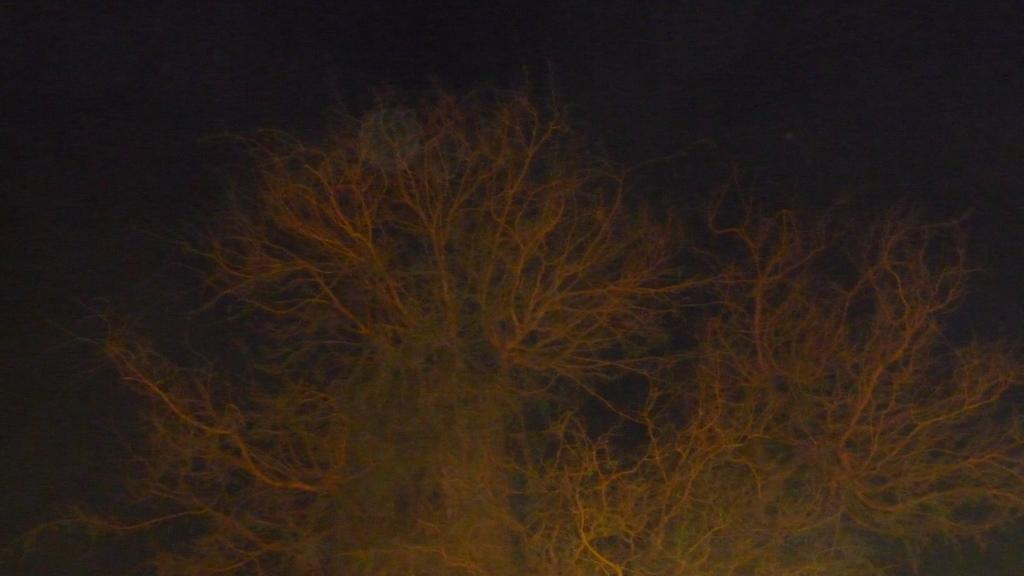What type of vegetation can be seen in the image? There are trees in the image. How would you describe the lighting in the image? The background of the image is dark. Who is the owner of the hall in the image? There is no hall present in the image, so it is not possible to determine the owner. 